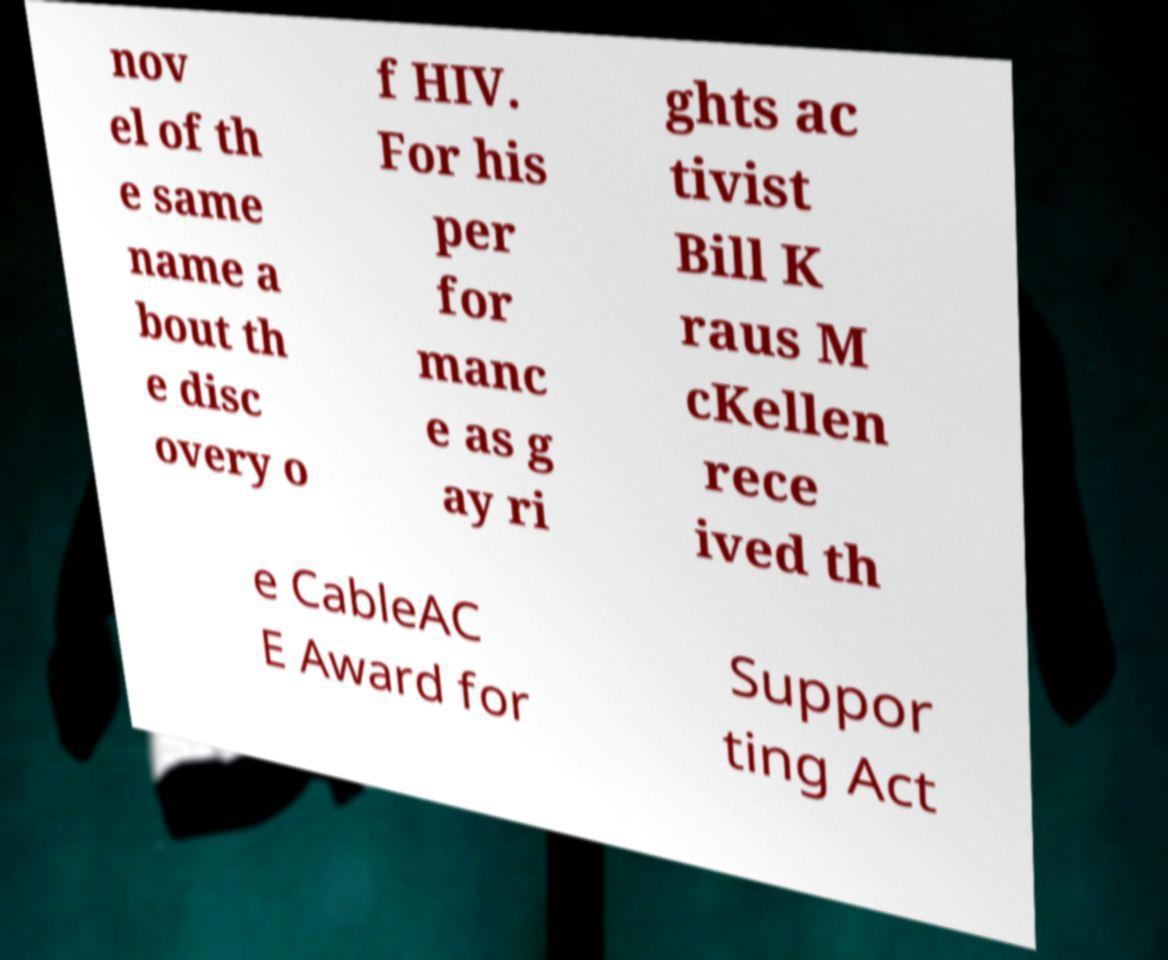Please read and relay the text visible in this image. What does it say? nov el of th e same name a bout th e disc overy o f HIV. For his per for manc e as g ay ri ghts ac tivist Bill K raus M cKellen rece ived th e CableAC E Award for Suppor ting Act 